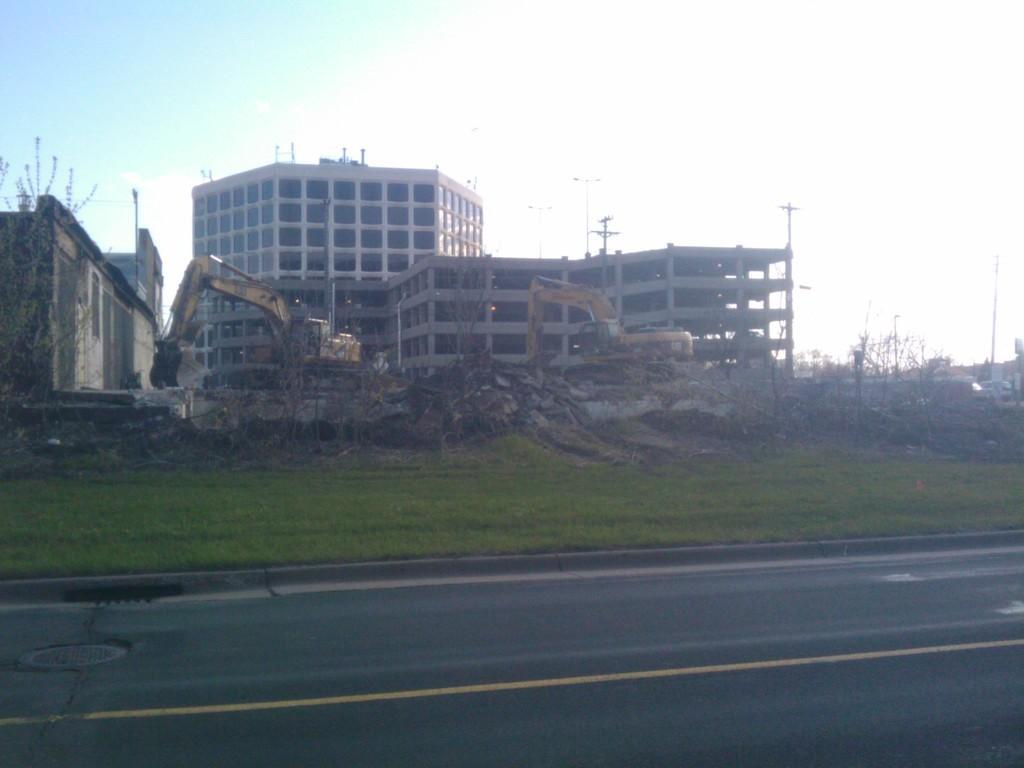Could you give a brief overview of what you see in this image? In the center of the image there are buildings. There are proclaimers. There is grass. At the bottom of the image there is road. 